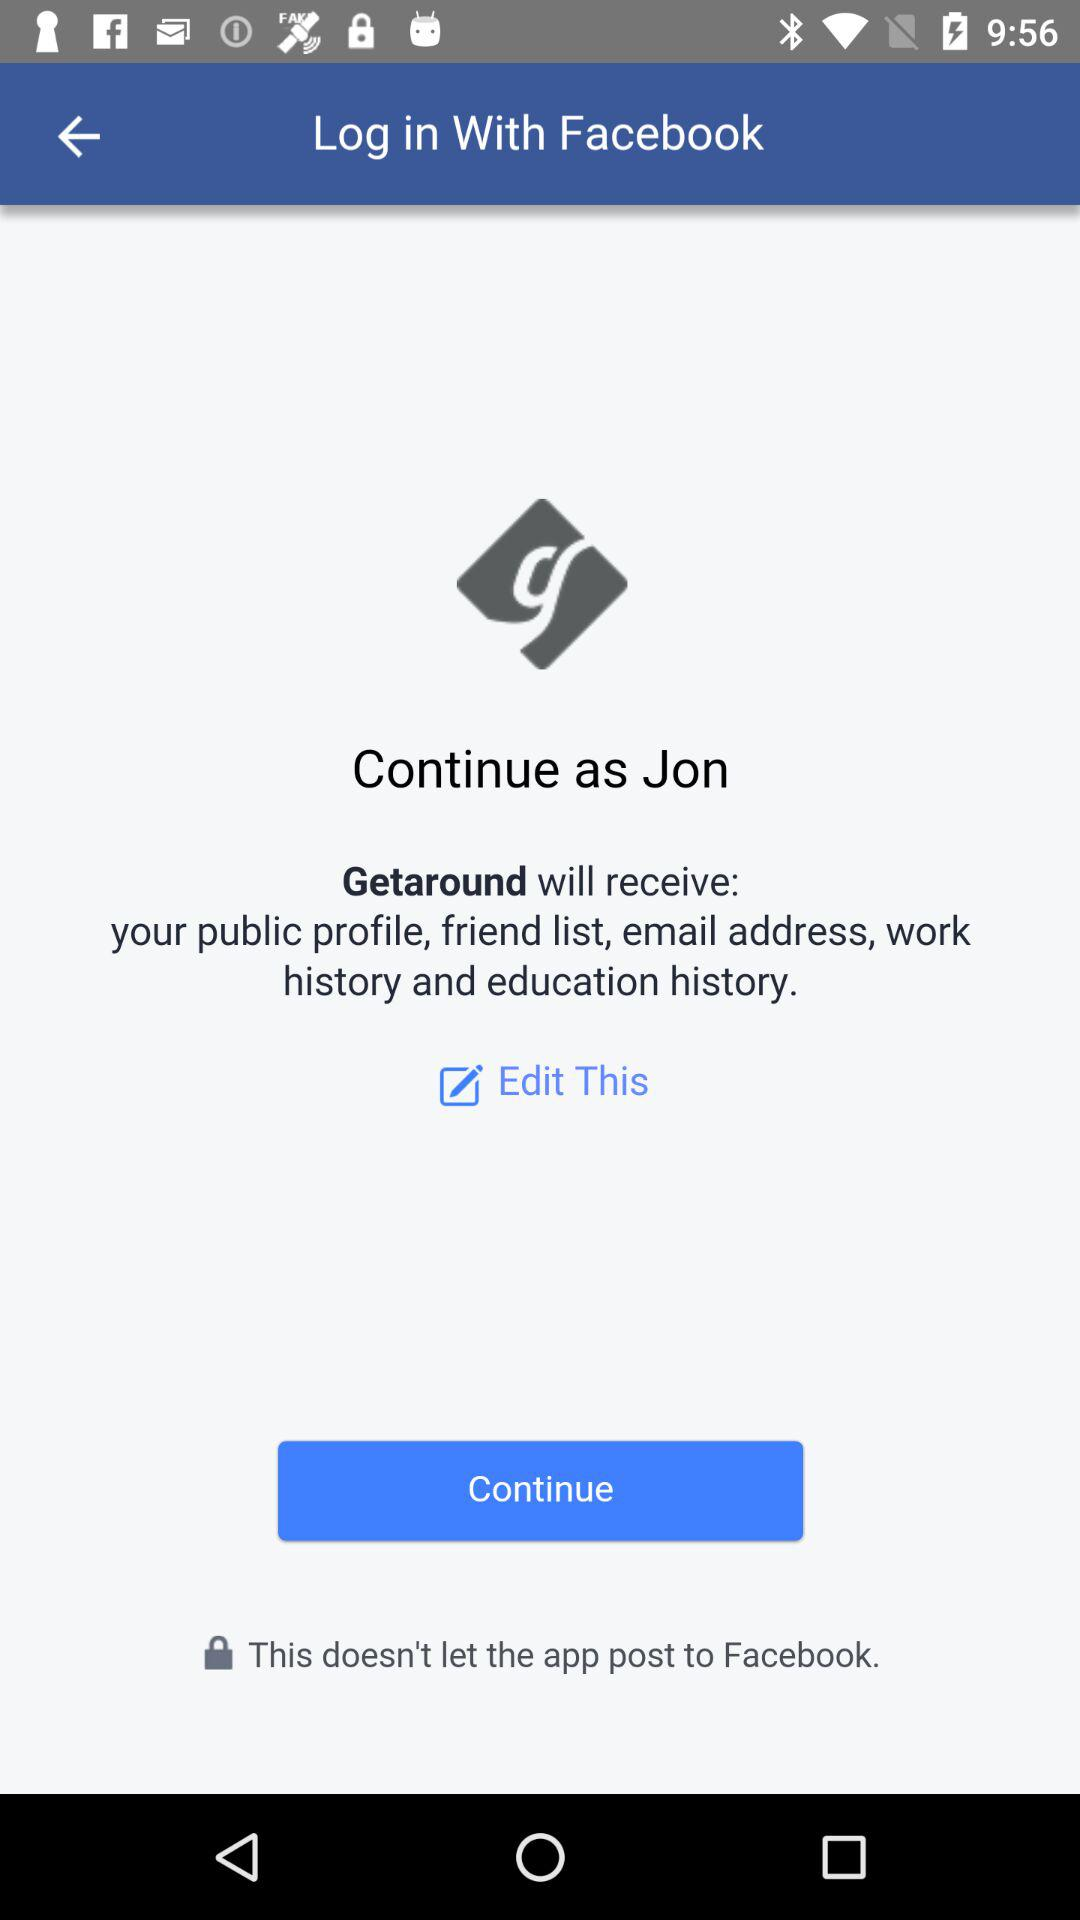What application will receive my public profile, email address, friend list and work history? The application that will receive your public profile, email address, friend list and work history is "Getaround". 